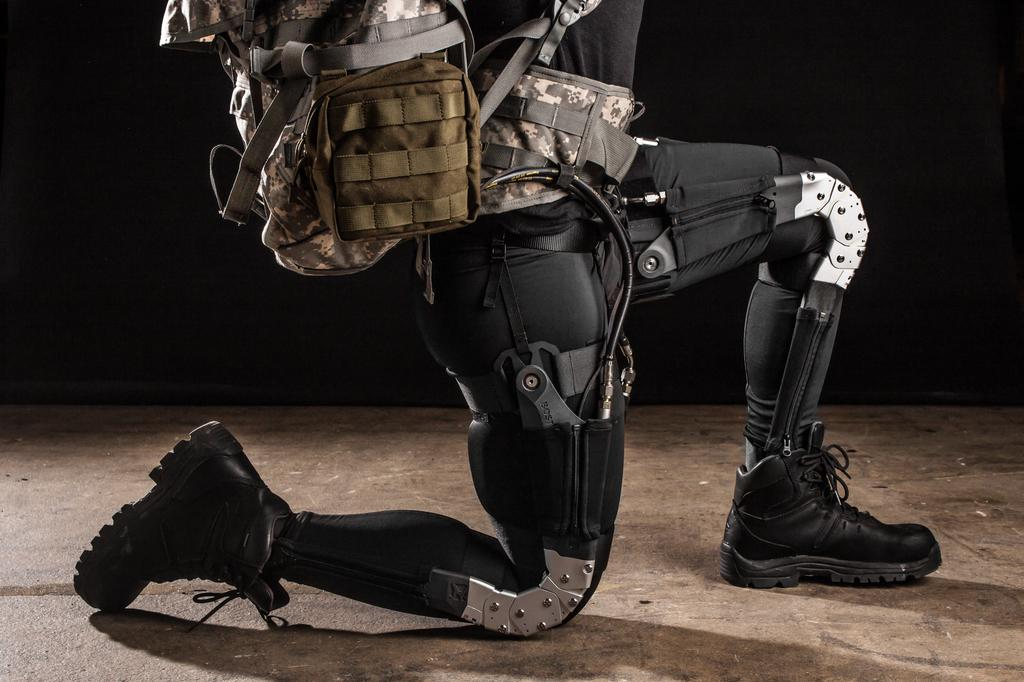What can be seen in the image? There is a person in the image. What type of footwear is the person wearing? The person is wearing black shoes. What is the person carrying in the image? The person is carrying a backpack. What is visible beneath the person in the image? The floor is visible in the image. What type of record can be seen on the wall in the image? There is no record present on the wall in the image. 